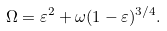Convert formula to latex. <formula><loc_0><loc_0><loc_500><loc_500>\Omega = \varepsilon ^ { 2 } + \omega ( 1 - \varepsilon ) ^ { 3 / 4 } .</formula> 